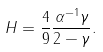<formula> <loc_0><loc_0><loc_500><loc_500>H = \frac { 4 } { 9 } \frac { \alpha ^ { - 1 } \gamma } { 2 - \gamma } .</formula> 